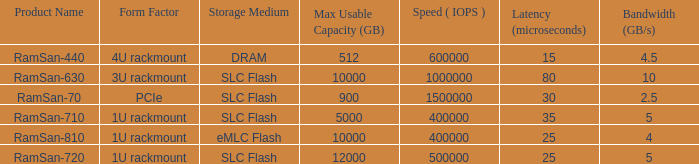Write the full table. {'header': ['Product Name', 'Form Factor', 'Storage Medium', 'Max Usable Capacity (GB)', 'Speed ( IOPS )', 'Latency (microseconds)', 'Bandwidth (GB/s)'], 'rows': [['RamSan-440', '4U rackmount', 'DRAM', '512', '600000', '15', '4.5'], ['RamSan-630', '3U rackmount', 'SLC Flash', '10000', '1000000', '80', '10'], ['RamSan-70', 'PCIe', 'SLC Flash', '900', '1500000', '30', '2.5'], ['RamSan-710', '1U rackmount', 'SLC Flash', '5000', '400000', '35', '5'], ['RamSan-810', '1U rackmount', 'eMLC Flash', '10000', '400000', '25', '4'], ['RamSan-720', '1U rackmount', 'SLC Flash', '12000', '500000', '25', '5']]} What are the input/output operations per second for emlc flash? 400000.0. 